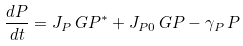<formula> <loc_0><loc_0><loc_500><loc_500>\frac { d P } { d t } = J _ { P } \, G P ^ { * } + J _ { P 0 } \, G P - \gamma _ { P } \, P</formula> 